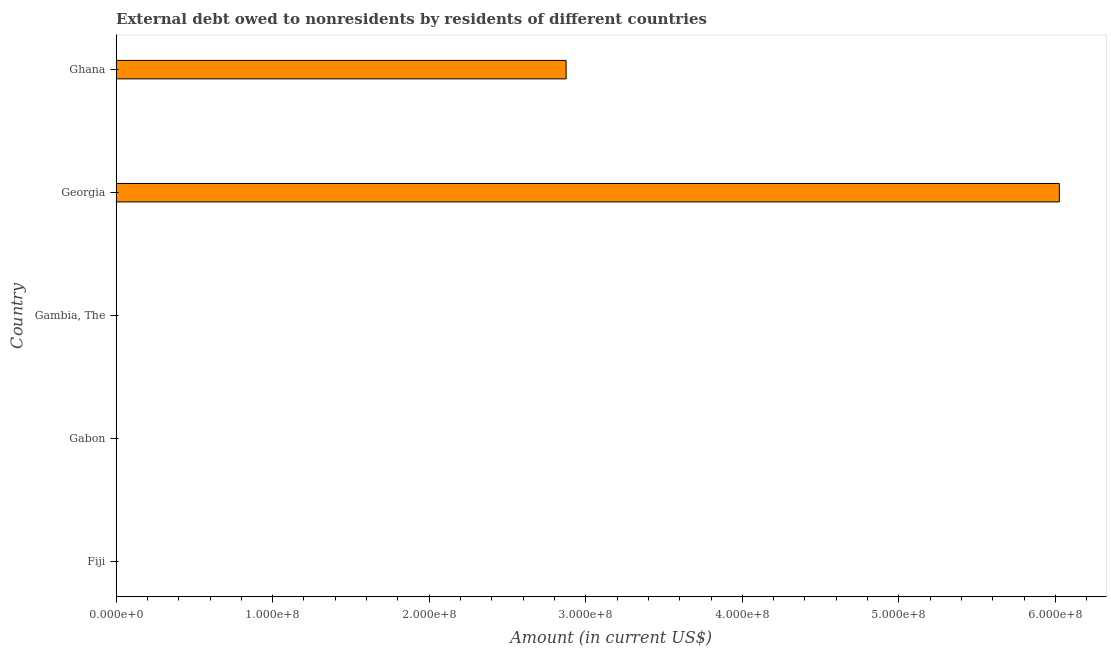What is the title of the graph?
Your answer should be compact. External debt owed to nonresidents by residents of different countries. What is the debt in Georgia?
Give a very brief answer. 6.03e+08. Across all countries, what is the maximum debt?
Give a very brief answer. 6.03e+08. Across all countries, what is the minimum debt?
Your answer should be compact. 0. In which country was the debt maximum?
Offer a terse response. Georgia. What is the sum of the debt?
Your response must be concise. 8.90e+08. What is the difference between the debt in Georgia and Ghana?
Keep it short and to the point. 3.15e+08. What is the average debt per country?
Ensure brevity in your answer.  1.78e+08. What is the median debt?
Your answer should be compact. 0. What is the difference between the highest and the lowest debt?
Your answer should be very brief. 6.03e+08. How many bars are there?
Provide a succinct answer. 2. What is the difference between two consecutive major ticks on the X-axis?
Keep it short and to the point. 1.00e+08. What is the Amount (in current US$) in Fiji?
Give a very brief answer. 0. What is the Amount (in current US$) of Gambia, The?
Keep it short and to the point. 0. What is the Amount (in current US$) in Georgia?
Provide a short and direct response. 6.03e+08. What is the Amount (in current US$) in Ghana?
Provide a short and direct response. 2.87e+08. What is the difference between the Amount (in current US$) in Georgia and Ghana?
Offer a very short reply. 3.15e+08. What is the ratio of the Amount (in current US$) in Georgia to that in Ghana?
Provide a short and direct response. 2.1. 